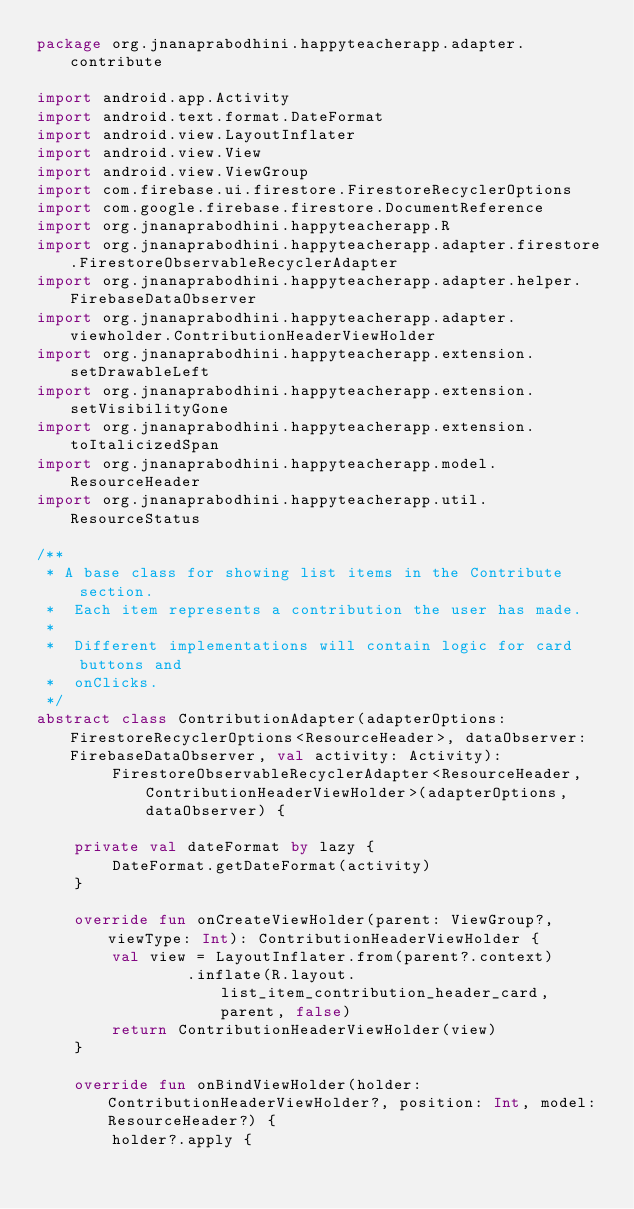Convert code to text. <code><loc_0><loc_0><loc_500><loc_500><_Kotlin_>package org.jnanaprabodhini.happyteacherapp.adapter.contribute

import android.app.Activity
import android.text.format.DateFormat
import android.view.LayoutInflater
import android.view.View
import android.view.ViewGroup
import com.firebase.ui.firestore.FirestoreRecyclerOptions
import com.google.firebase.firestore.DocumentReference
import org.jnanaprabodhini.happyteacherapp.R
import org.jnanaprabodhini.happyteacherapp.adapter.firestore.FirestoreObservableRecyclerAdapter
import org.jnanaprabodhini.happyteacherapp.adapter.helper.FirebaseDataObserver
import org.jnanaprabodhini.happyteacherapp.adapter.viewholder.ContributionHeaderViewHolder
import org.jnanaprabodhini.happyteacherapp.extension.setDrawableLeft
import org.jnanaprabodhini.happyteacherapp.extension.setVisibilityGone
import org.jnanaprabodhini.happyteacherapp.extension.toItalicizedSpan
import org.jnanaprabodhini.happyteacherapp.model.ResourceHeader
import org.jnanaprabodhini.happyteacherapp.util.ResourceStatus

/**
 * A base class for showing list items in the Contribute section.
 *  Each item represents a contribution the user has made.
 *
 *  Different implementations will contain logic for card buttons and
 *  onClicks.
 */
abstract class ContributionAdapter(adapterOptions: FirestoreRecyclerOptions<ResourceHeader>, dataObserver: FirebaseDataObserver, val activity: Activity):
        FirestoreObservableRecyclerAdapter<ResourceHeader, ContributionHeaderViewHolder>(adapterOptions, dataObserver) {

    private val dateFormat by lazy {
        DateFormat.getDateFormat(activity)
    }

    override fun onCreateViewHolder(parent: ViewGroup?, viewType: Int): ContributionHeaderViewHolder {
        val view = LayoutInflater.from(parent?.context)
                .inflate(R.layout.list_item_contribution_header_card, parent, false)
        return ContributionHeaderViewHolder(view)
    }

    override fun onBindViewHolder(holder: ContributionHeaderViewHolder?, position: Int, model: ResourceHeader?) {
        holder?.apply {
</code> 